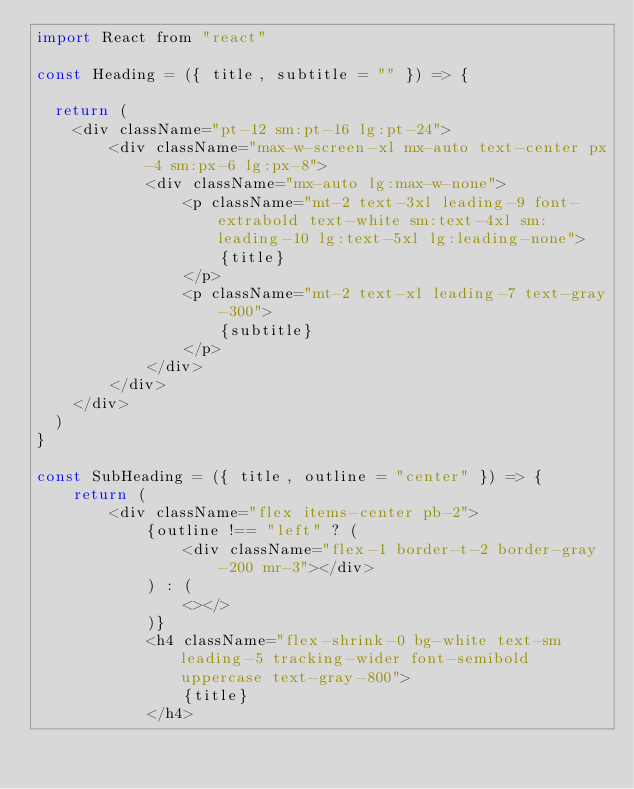<code> <loc_0><loc_0><loc_500><loc_500><_JavaScript_>import React from "react"

const Heading = ({ title, subtitle = "" }) => {

  return (
    <div className="pt-12 sm:pt-16 lg:pt-24">
        <div className="max-w-screen-xl mx-auto text-center px-4 sm:px-6 lg:px-8">
            <div className="mx-auto lg:max-w-none">
                <p className="mt-2 text-3xl leading-9 font-extrabold text-white sm:text-4xl sm:leading-10 lg:text-5xl lg:leading-none">
                    {title}
                </p>
                <p className="mt-2 text-xl leading-7 text-gray-300">
                    {subtitle}
                </p>
            </div>
        </div>
    </div>
  )
}

const SubHeading = ({ title, outline = "center" }) => {
    return (
        <div className="flex items-center pb-2">
            {outline !== "left" ? (
                <div className="flex-1 border-t-2 border-gray-200 mr-3"></div>
            ) : (
                <></>
            )}
            <h4 className="flex-shrink-0 bg-white text-sm leading-5 tracking-wider font-semibold uppercase text-gray-800">
                {title}
            </h4></code> 